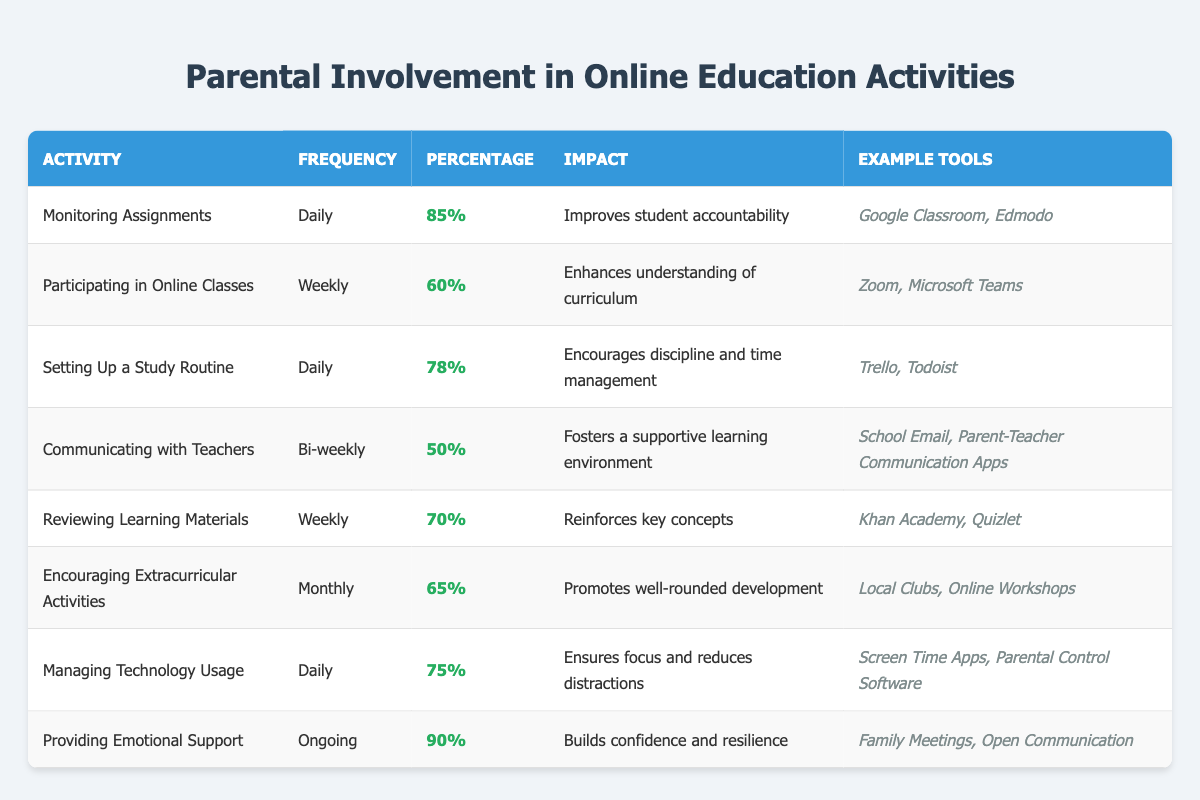What is the percentage of parents participating in online classes weekly? The table states that 60% of parents participate in online classes weekly.
Answer: 60% Which activity has the highest percentage of parental involvement? The highest percentage of parental involvement is in "Providing Emotional Support," which has a percentage of 90%.
Answer: 90% How often do parents communicate with teachers according to the data? The table shows that parents communicate with teachers bi-weekly.
Answer: Bi-weekly What percentage of parents manage technology usage daily? The table indicates that 75% of parents manage technology usage daily.
Answer: 75% What is the average percentage of parental involvement across all activities listed? The percentages are 85, 60, 78, 50, 70, 65, 75, and 90. Adding these gives  85 + 60 + 78 + 50 + 70 + 65 + 75 + 90 =  570. There are 8 activities, so the average is 570 / 8 = 71.25.
Answer: 71.25 Is the impact of "Reviewing Learning Materials" described in the table? Yes, the impact of this activity is that it reinforces key concepts.
Answer: Yes How does the frequency of "Encouraging Extracurricular Activities" compare to "Communicating with Teachers"? "Encouraging Extracurricular Activities" occurs monthly while "Communicating with Teachers" occurs bi-weekly. Monthly is less frequent than bi-weekly.
Answer: Monthly is less frequent Which activity has a percentage below 70%? The activities "Participating in Online Classes" at 60% and "Communicating with Teachers" at 50% both have percentages below 70%.
Answer: 60% and 50% If a parent manages technology usage daily, how many activities do they engage in daily? The activities listed as daily involvement are "Monitoring Assignments," "Setting Up a Study Routine," and "Managing Technology Usage," totaling three daily activities.
Answer: 3 Which activity has the least percent of parental involvement? "Communicating with Teachers" has the least percent of parental involvement at 50%.
Answer: 50% 